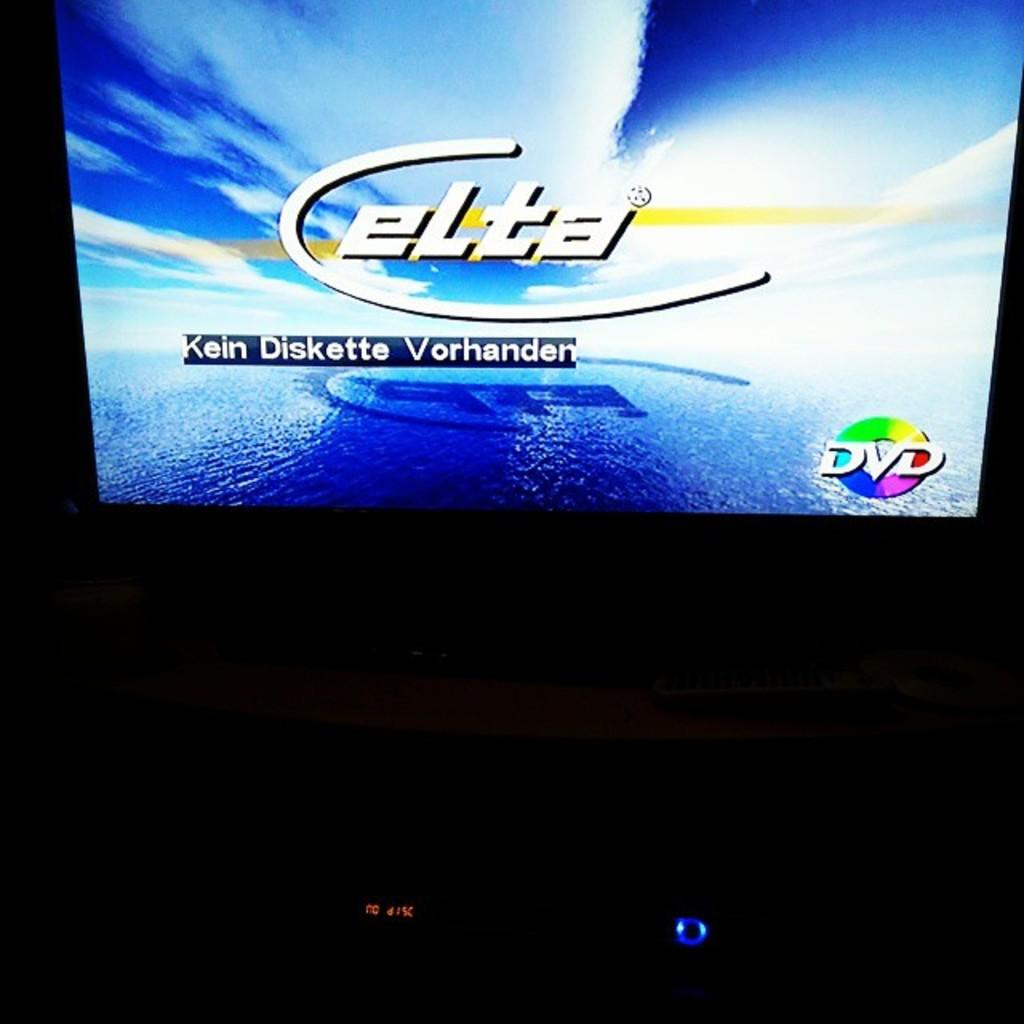Provide a one-sentence caption for the provided image. Elta Kein Diskette Vorhanded wrote on a television that playing a dvd. 